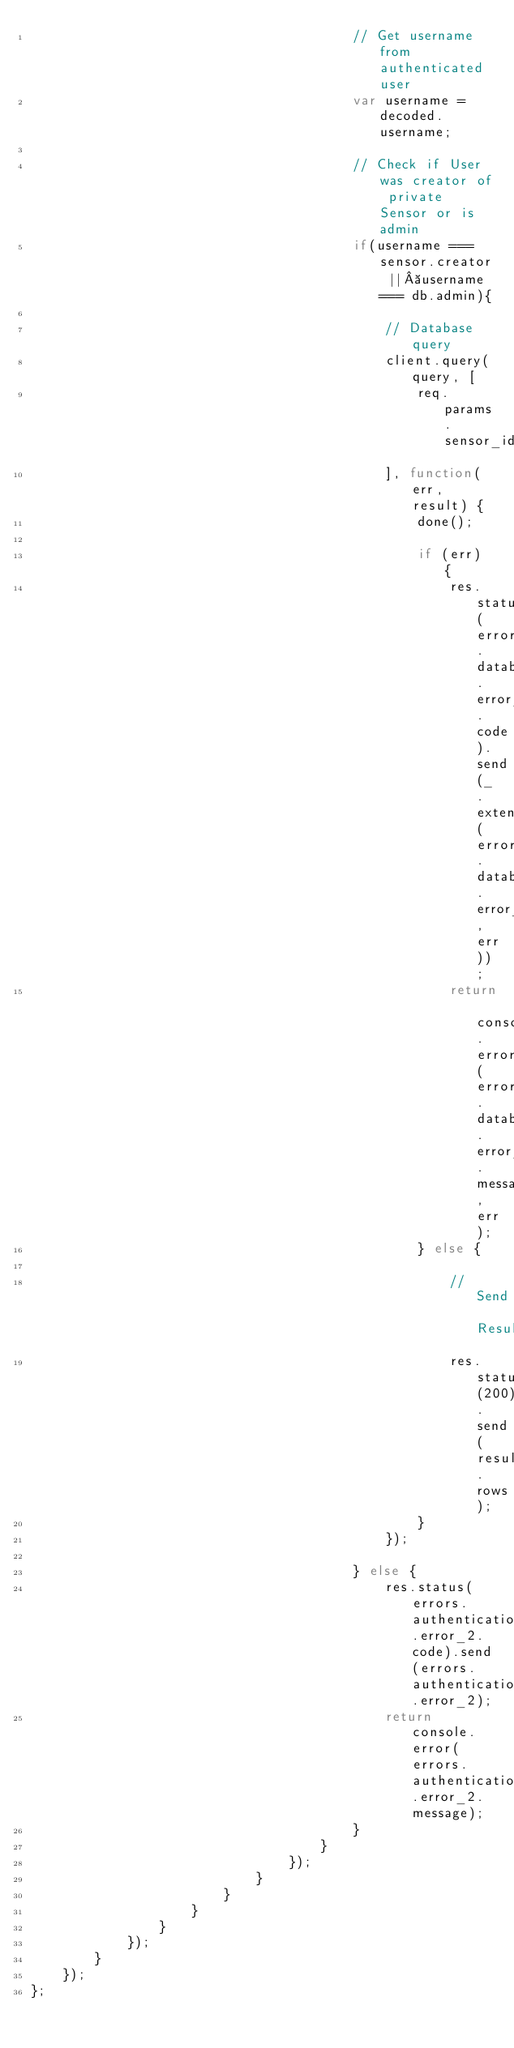Convert code to text. <code><loc_0><loc_0><loc_500><loc_500><_JavaScript_>                                        // Get username from authenticated user
                                        var username = decoded.username;

                                        // Check if User was creator of private Sensor or is admin
                                        if(username === sensor.creator || username === db.admin){

                                            // Database query
                                            client.query(query, [
                                                req.params.sensor_id
                                            ], function(err, result) {
                                                done();

                                                if (err) {
                                                    res.status(errors.database.error_2.code).send(_.extend(errors.database.error_2, err));
                                                    return console.error(errors.database.error_2.message, err);
                                                } else {

                                                    // Send Result
                                                    res.status(200).send(result.rows);
                                                }
                                            });

                                        } else {
                                            res.status(errors.authentication.error_2.code).send(errors.authentication.error_2);
                                            return console.error(errors.authentication.error_2.message);
                                        }
                                    }
                                });
                            }
                        }
                    }
                }
            });
        }
    });
};
</code> 